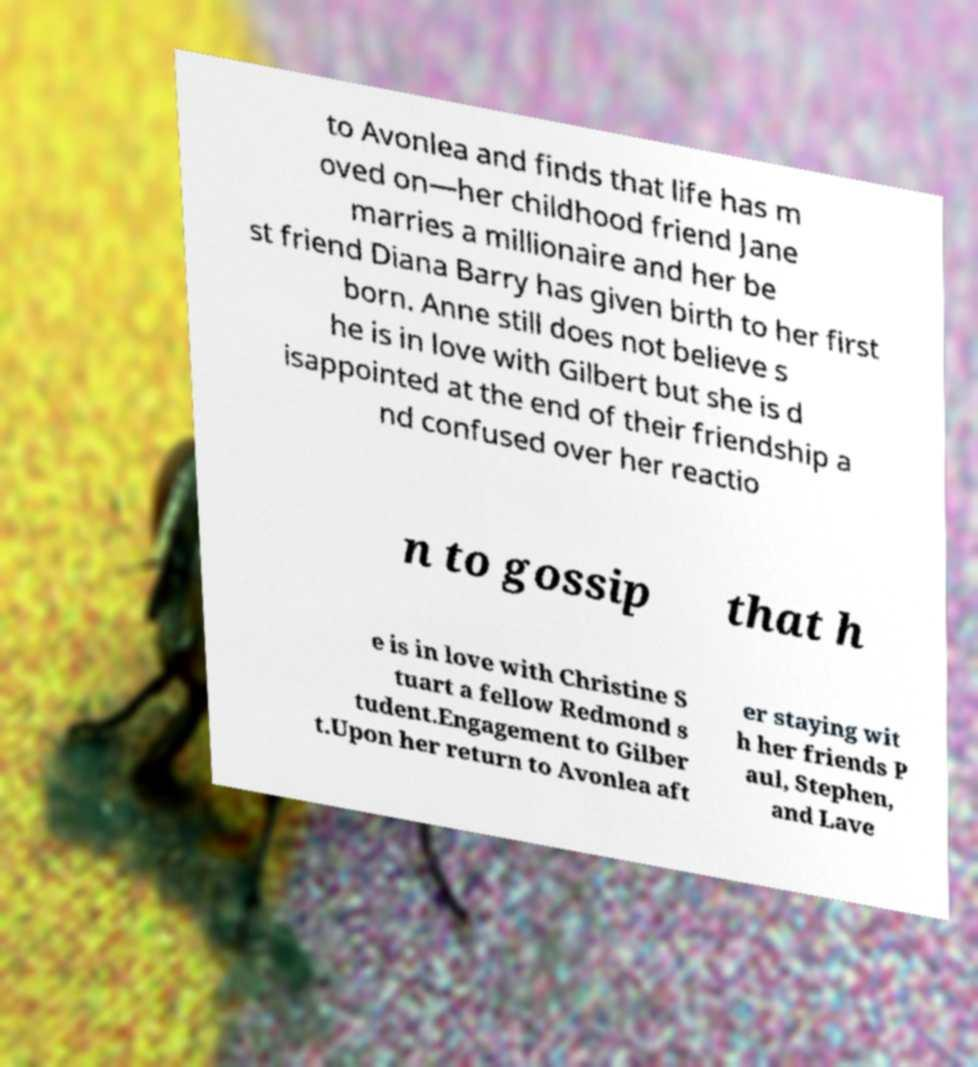Please read and relay the text visible in this image. What does it say? to Avonlea and finds that life has m oved on—her childhood friend Jane marries a millionaire and her be st friend Diana Barry has given birth to her first born. Anne still does not believe s he is in love with Gilbert but she is d isappointed at the end of their friendship a nd confused over her reactio n to gossip that h e is in love with Christine S tuart a fellow Redmond s tudent.Engagement to Gilber t.Upon her return to Avonlea aft er staying wit h her friends P aul, Stephen, and Lave 